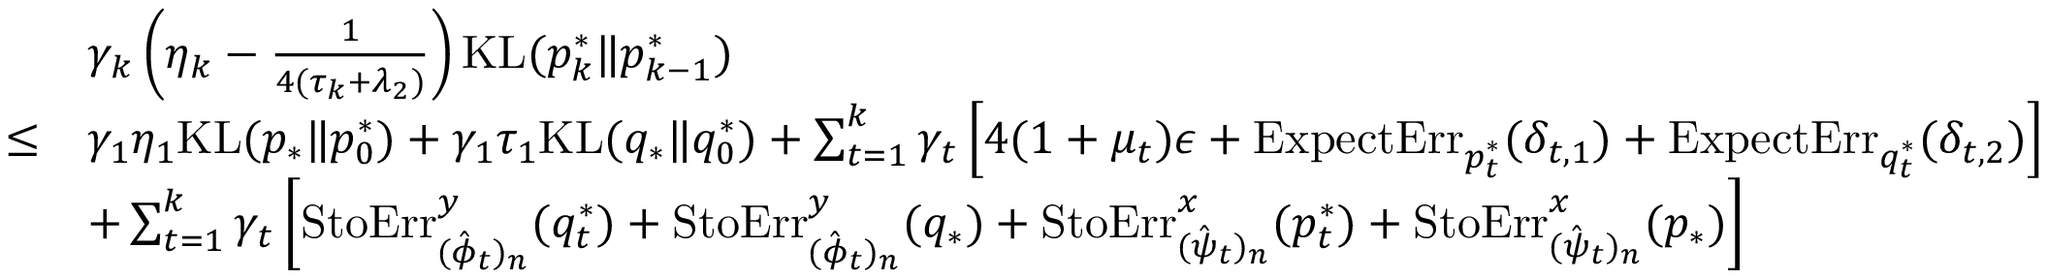Convert formula to latex. <formula><loc_0><loc_0><loc_500><loc_500>\begin{array} { r l } & { \gamma _ { k } \left ( \eta _ { k } - \frac { 1 } { 4 ( \tau _ { k } + \lambda _ { 2 } ) } \right ) K L ( p _ { k } ^ { * } \| p _ { k - 1 } ^ { * } ) } \\ { \leq } & { \gamma _ { 1 } \eta _ { 1 } K L ( p _ { * } \| p _ { 0 } ^ { * } ) + \gamma _ { 1 } \tau _ { 1 } K L ( q _ { * } \| q _ { 0 } ^ { * } ) + \sum _ { t = 1 } ^ { k } \gamma _ { t } \left [ 4 ( 1 + \mu _ { t } ) \epsilon + E x p e c t E r r _ { p _ { t } ^ { * } } ( \delta _ { t , 1 } ) + E x p e c t E r r _ { q _ { t } ^ { * } } ( \delta _ { t , 2 } ) \right ] } \\ & { + \sum _ { t = 1 } ^ { k } \gamma _ { t } \left [ S t o E r r _ { ( \hat { \phi } _ { t } ) _ { n } } ^ { y } ( q _ { t } ^ { * } ) + S t o E r r _ { ( \hat { \phi } _ { t } ) _ { n } } ^ { y } ( q _ { * } ) + S t o E r r _ { ( \hat { \psi } _ { t } ) _ { n } } ^ { x } ( p _ { t } ^ { * } ) + S t o E r r _ { ( \hat { \psi } _ { t } ) _ { n } } ^ { x } ( p _ { * } ) \right ] } \end{array}</formula> 